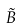<formula> <loc_0><loc_0><loc_500><loc_500>\tilde { B }</formula> 